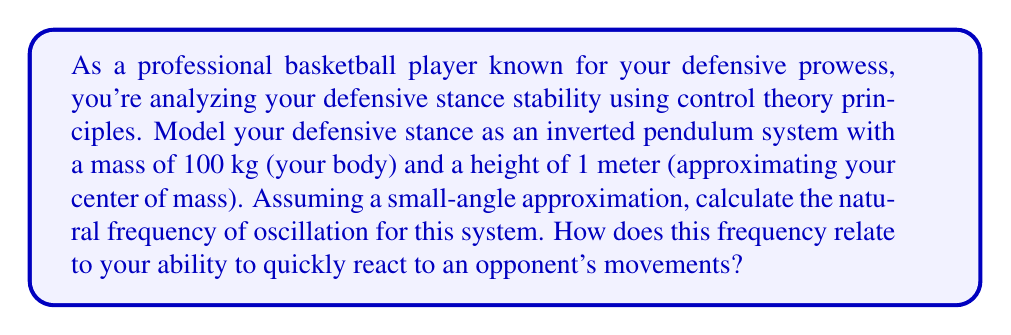Help me with this question. To analyze the stability of a defensive stance using control theory, we can model it as an inverted pendulum system. This is appropriate because a player's defensive stance involves balancing the body in an upright position, similar to an inverted pendulum.

Let's break down the problem step-by-step:

1) The equation of motion for a simple inverted pendulum is:

   $$\ddot{\theta} - \frac{g}{l}\theta = 0$$

   where $\theta$ is the angle from vertical, $g$ is the acceleration due to gravity, and $l$ is the length of the pendulum (in this case, the height of the center of mass).

2) The natural frequency of oscillation, $\omega_n$, for this system is given by:

   $$\omega_n = \sqrt{\frac{g}{l}}$$

3) Given:
   - $g = 9.81 \text{ m/s}^2$ (acceleration due to gravity)
   - $l = 1 \text{ m}$ (height of center of mass)

4) Plugging these values into the equation:

   $$\omega_n = \sqrt{\frac{9.81}{1}} = \sqrt{9.81} \approx 3.13 \text{ rad/s}$$

5) To convert this to Hz, we divide by $2\pi$:

   $$f_n = \frac{\omega_n}{2\pi} \approx 0.50 \text{ Hz}$$

This frequency relates to your ability to react quickly to an opponent's movements in the following ways:

1) A higher natural frequency indicates a more responsive system. At 0.50 Hz, your stance can theoretically complete one oscillation every 2 seconds.

2) In practice, this means you can shift your weight from one foot to the other relatively quickly, allowing you to respond to sudden changes in your opponent's direction.

3) However, in a real game situation, you would aim to maintain your balance without actually oscillating. The natural frequency gives you an idea of how quickly you can recover if you're slightly off-balance.

4) A lower center of mass (smaller $l$) would increase this frequency, explaining why a lower defensive stance often leads to quicker reactions.

5) As a professional player, you likely have developed muscles and reflexes that allow you to react even faster than this natural frequency would suggest, but this model provides a baseline for understanding the physics of your defensive stance.
Answer: The natural frequency of oscillation for the defensive stance modeled as an inverted pendulum is approximately 3.13 rad/s or 0.50 Hz. This frequency indicates that the player can theoretically shift their weight from one foot to the other every 2 seconds, providing a baseline for quick reactions to opponent movements in a defensive stance. 